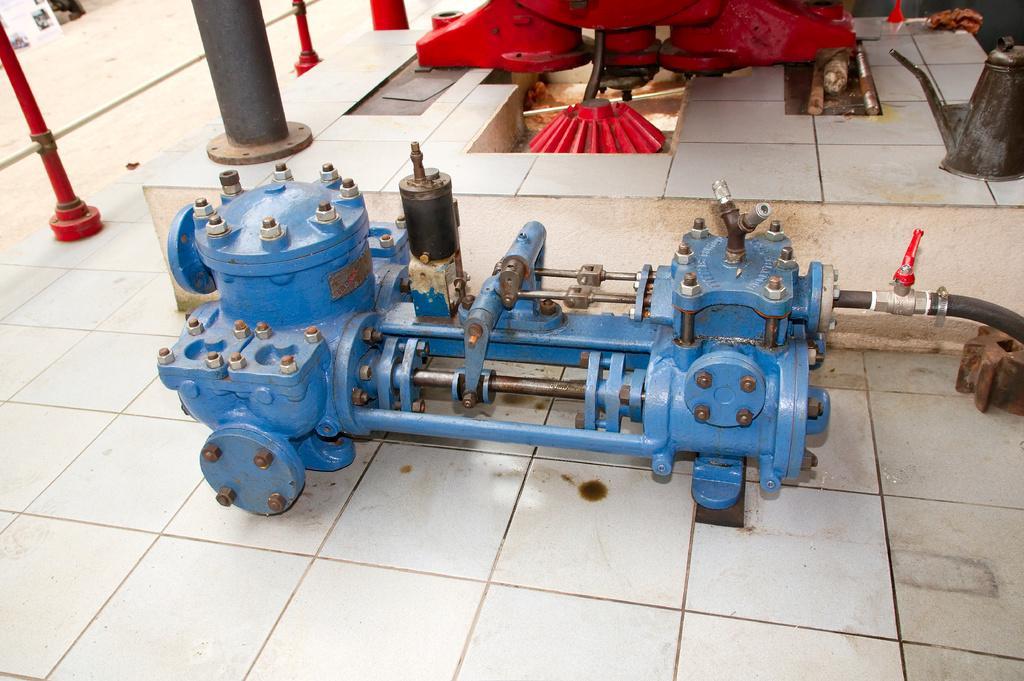Please provide a concise description of this image. In the foreground of the image we can see a machine which is in blue color is on the ground and in the background of the image there is red color machine which is also on the ground, there is oil can and on left side of the image there is fencing. 